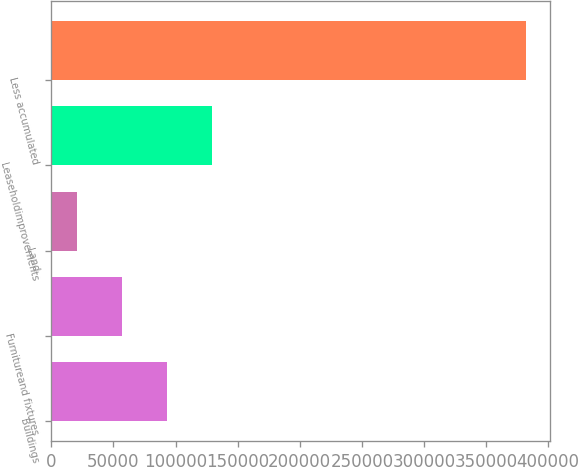Convert chart to OTSL. <chart><loc_0><loc_0><loc_500><loc_500><bar_chart><fcel>Buildings<fcel>Furnitureand fixtures<fcel>Land<fcel>Leaseholdimprovements<fcel>Less accumulated<nl><fcel>92792<fcel>56603<fcel>20414<fcel>128981<fcel>382304<nl></chart> 